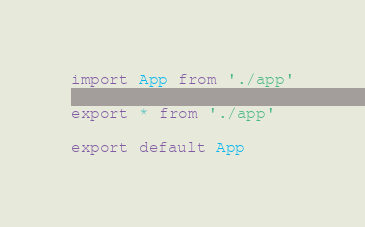Convert code to text. <code><loc_0><loc_0><loc_500><loc_500><_TypeScript_>import App from './app'

export * from './app'

export default App
</code> 